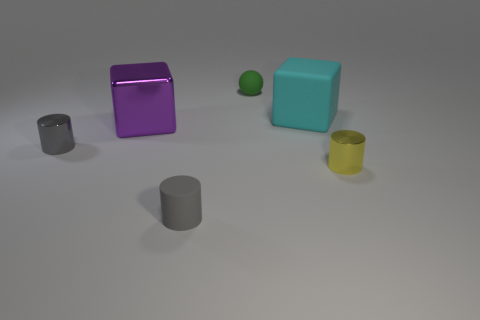What number of cylinders are tiny yellow things or cyan objects?
Your answer should be compact. 1. What size is the ball that is made of the same material as the big cyan cube?
Your answer should be compact. Small. Does the green sphere that is behind the metal cube have the same size as the shiny cylinder that is to the right of the cyan matte thing?
Offer a very short reply. Yes. How many things are gray things or gray matte things?
Keep it short and to the point. 2. What is the shape of the small green object?
Provide a short and direct response. Sphere. There is a purple object that is the same shape as the cyan matte thing; what size is it?
Keep it short and to the point. Large. There is a cyan matte block behind the small rubber object in front of the big purple object; what size is it?
Offer a very short reply. Large. Is the number of big purple metal blocks in front of the purple object the same as the number of cylinders?
Make the answer very short. No. What number of other objects are the same color as the small matte cylinder?
Ensure brevity in your answer.  1. Are there fewer tiny gray cylinders right of the small rubber cylinder than brown balls?
Provide a succinct answer. No. 